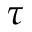<formula> <loc_0><loc_0><loc_500><loc_500>\tau</formula> 